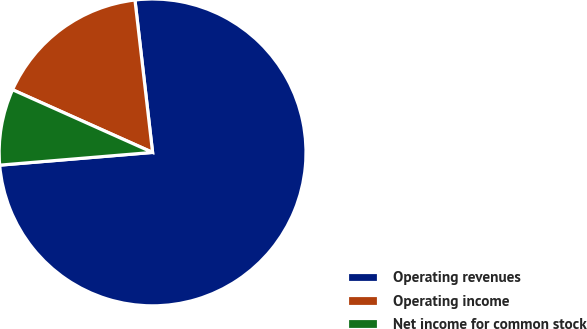<chart> <loc_0><loc_0><loc_500><loc_500><pie_chart><fcel>Operating revenues<fcel>Operating income<fcel>Net income for common stock<nl><fcel>75.51%<fcel>16.47%<fcel>8.02%<nl></chart> 